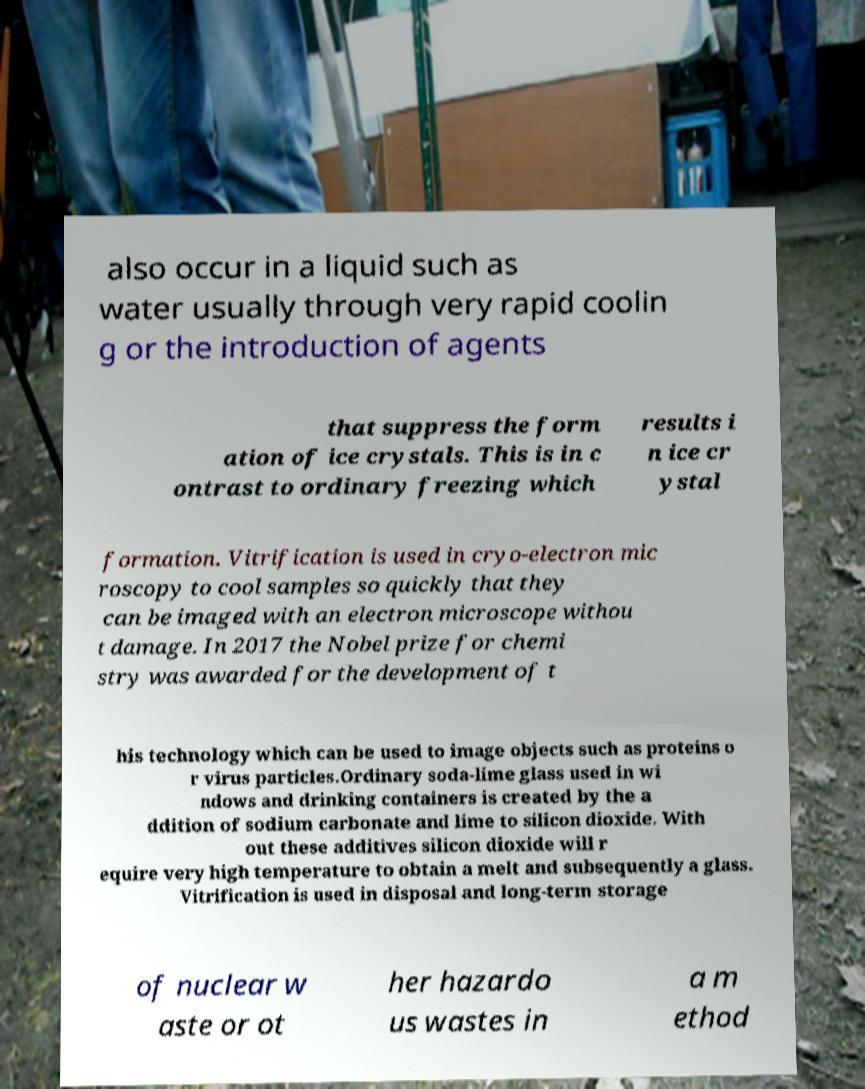Could you extract and type out the text from this image? also occur in a liquid such as water usually through very rapid coolin g or the introduction of agents that suppress the form ation of ice crystals. This is in c ontrast to ordinary freezing which results i n ice cr ystal formation. Vitrification is used in cryo-electron mic roscopy to cool samples so quickly that they can be imaged with an electron microscope withou t damage. In 2017 the Nobel prize for chemi stry was awarded for the development of t his technology which can be used to image objects such as proteins o r virus particles.Ordinary soda-lime glass used in wi ndows and drinking containers is created by the a ddition of sodium carbonate and lime to silicon dioxide. With out these additives silicon dioxide will r equire very high temperature to obtain a melt and subsequently a glass. Vitrification is used in disposal and long-term storage of nuclear w aste or ot her hazardo us wastes in a m ethod 